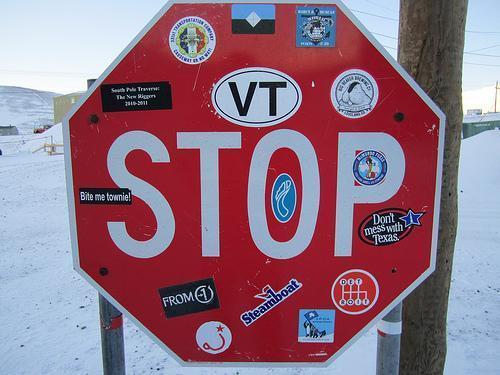How many sides does the sign have?
Give a very brief answer. 8. 